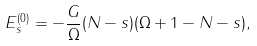Convert formula to latex. <formula><loc_0><loc_0><loc_500><loc_500>E ^ { ( 0 ) } _ { s } = - \frac { G } { \Omega } ( N - s ) ( \Omega + 1 - N - s ) ,</formula> 